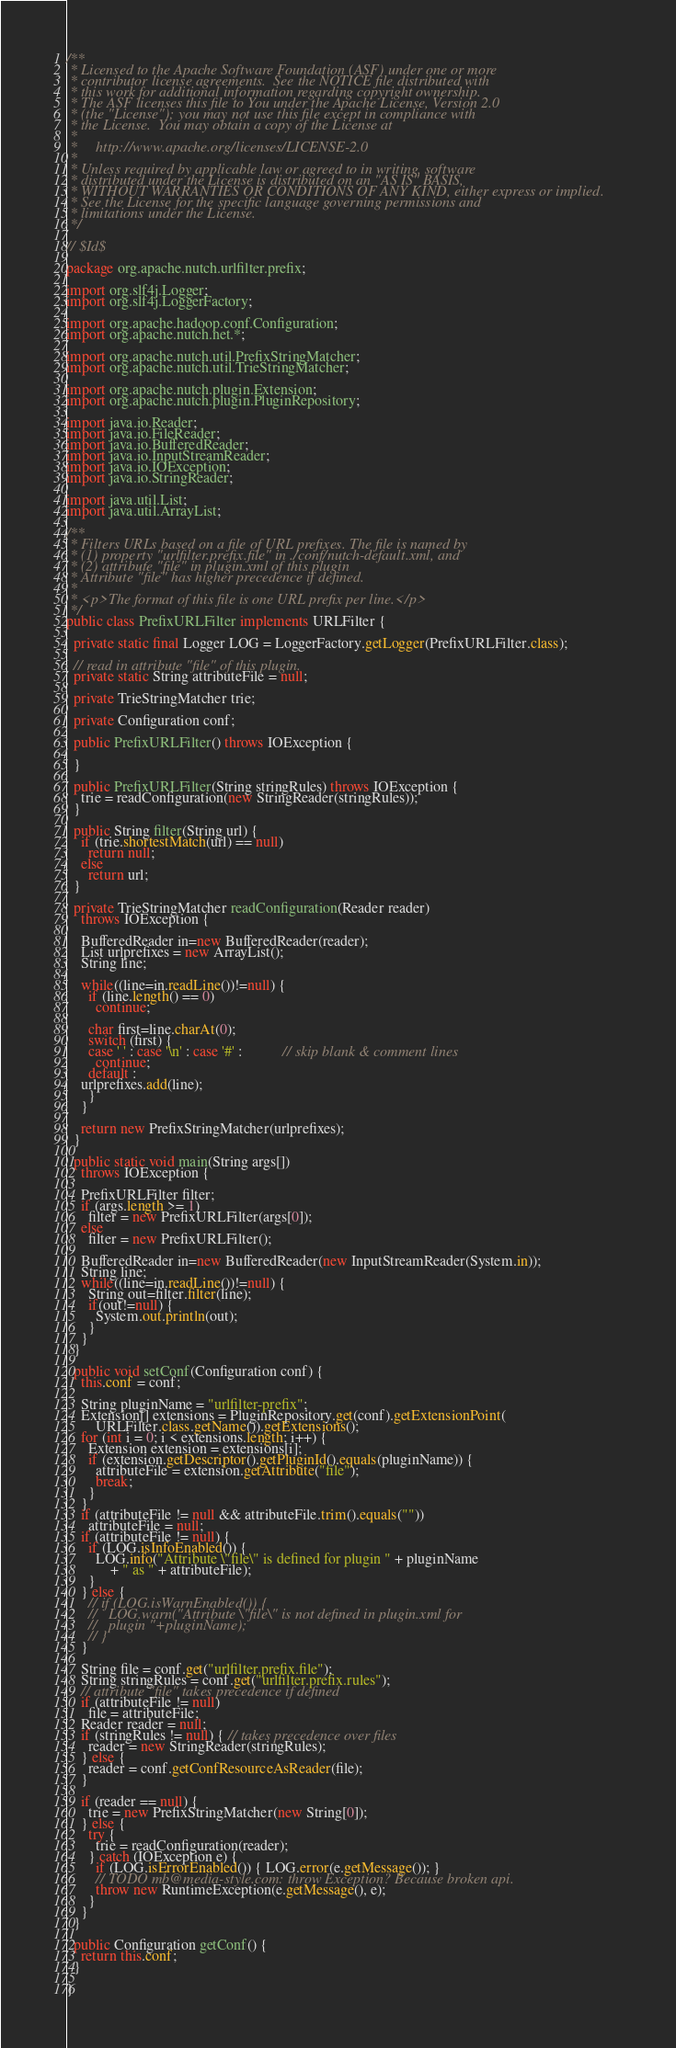Convert code to text. <code><loc_0><loc_0><loc_500><loc_500><_Java_>/**
 * Licensed to the Apache Software Foundation (ASF) under one or more
 * contributor license agreements.  See the NOTICE file distributed with
 * this work for additional information regarding copyright ownership.
 * The ASF licenses this file to You under the Apache License, Version 2.0
 * (the "License"); you may not use this file except in compliance with
 * the License.  You may obtain a copy of the License at
 *
 *     http://www.apache.org/licenses/LICENSE-2.0
 *
 * Unless required by applicable law or agreed to in writing, software
 * distributed under the License is distributed on an "AS IS" BASIS,
 * WITHOUT WARRANTIES OR CONDITIONS OF ANY KIND, either express or implied.
 * See the License for the specific language governing permissions and
 * limitations under the License.
 */

// $Id$

package org.apache.nutch.urlfilter.prefix;

import org.slf4j.Logger;
import org.slf4j.LoggerFactory;

import org.apache.hadoop.conf.Configuration;
import org.apache.nutch.net.*;

import org.apache.nutch.util.PrefixStringMatcher;
import org.apache.nutch.util.TrieStringMatcher;

import org.apache.nutch.plugin.Extension;
import org.apache.nutch.plugin.PluginRepository;

import java.io.Reader;
import java.io.FileReader;
import java.io.BufferedReader;
import java.io.InputStreamReader;
import java.io.IOException;
import java.io.StringReader;

import java.util.List;
import java.util.ArrayList;

/**
 * Filters URLs based on a file of URL prefixes. The file is named by
 * (1) property "urlfilter.prefix.file" in ./conf/nutch-default.xml, and
 * (2) attribute "file" in plugin.xml of this plugin
 * Attribute "file" has higher precedence if defined.
 *
 * <p>The format of this file is one URL prefix per line.</p>
 */
public class PrefixURLFilter implements URLFilter {

  private static final Logger LOG = LoggerFactory.getLogger(PrefixURLFilter.class);

  // read in attribute "file" of this plugin.
  private static String attributeFile = null;

  private TrieStringMatcher trie;

  private Configuration conf;

  public PrefixURLFilter() throws IOException {
   
  }

  public PrefixURLFilter(String stringRules) throws IOException {
    trie = readConfiguration(new StringReader(stringRules));
  }

  public String filter(String url) {
    if (trie.shortestMatch(url) == null)
      return null;
    else
      return url;
  }

  private TrieStringMatcher readConfiguration(Reader reader)
    throws IOException {
    
    BufferedReader in=new BufferedReader(reader);
    List urlprefixes = new ArrayList();
    String line;

    while((line=in.readLine())!=null) {
      if (line.length() == 0)
        continue;

      char first=line.charAt(0);
      switch (first) {
      case ' ' : case '\n' : case '#' :           // skip blank & comment lines
        continue;
      default :
	urlprefixes.add(line);
      }
    }

    return new PrefixStringMatcher(urlprefixes);
  }

  public static void main(String args[])
    throws IOException {
    
    PrefixURLFilter filter;
    if (args.length >= 1)
      filter = new PrefixURLFilter(args[0]);
    else
      filter = new PrefixURLFilter();
    
    BufferedReader in=new BufferedReader(new InputStreamReader(System.in));
    String line;
    while((line=in.readLine())!=null) {
      String out=filter.filter(line);
      if(out!=null) {
        System.out.println(out);
      }
    }
  }

  public void setConf(Configuration conf) {
    this.conf = conf;

    String pluginName = "urlfilter-prefix";
    Extension[] extensions = PluginRepository.get(conf).getExtensionPoint(
        URLFilter.class.getName()).getExtensions();
    for (int i = 0; i < extensions.length; i++) {
      Extension extension = extensions[i];
      if (extension.getDescriptor().getPluginId().equals(pluginName)) {
        attributeFile = extension.getAttribute("file");
        break;
      }
    }
    if (attributeFile != null && attributeFile.trim().equals(""))
      attributeFile = null;
    if (attributeFile != null) {
      if (LOG.isInfoEnabled()) {
        LOG.info("Attribute \"file\" is defined for plugin " + pluginName
            + " as " + attributeFile);
      }
    } else {
      // if (LOG.isWarnEnabled()) {
      //   LOG.warn("Attribute \"file\" is not defined in plugin.xml for
      //   plugin "+pluginName);
      // }
    }

    String file = conf.get("urlfilter.prefix.file");
    String stringRules = conf.get("urlfilter.prefix.rules");
    // attribute "file" takes precedence if defined
    if (attributeFile != null)
      file = attributeFile;
    Reader reader = null;
    if (stringRules != null) { // takes precedence over files
      reader = new StringReader(stringRules);
    } else {
      reader = conf.getConfResourceAsReader(file);
    }

    if (reader == null) {
      trie = new PrefixStringMatcher(new String[0]);
    } else {
      try {
        trie = readConfiguration(reader);
      } catch (IOException e) {
        if (LOG.isErrorEnabled()) { LOG.error(e.getMessage()); }
        // TODO mb@media-style.com: throw Exception? Because broken api.
        throw new RuntimeException(e.getMessage(), e);
      }
    }
  }

  public Configuration getConf() {
    return this.conf;
  }
  
}
</code> 